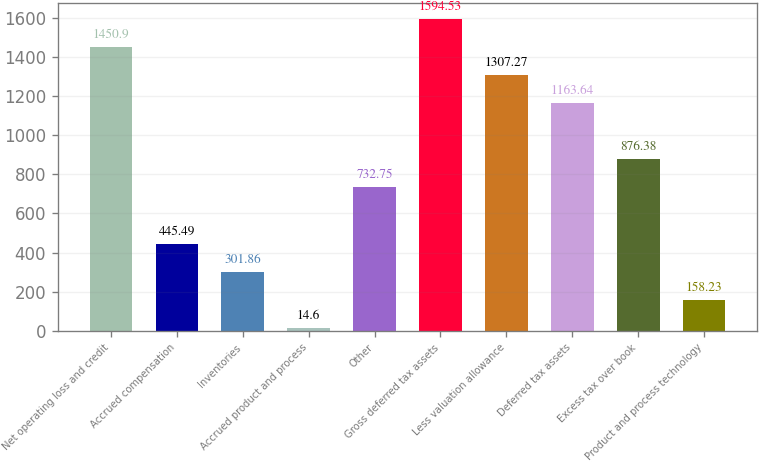Convert chart. <chart><loc_0><loc_0><loc_500><loc_500><bar_chart><fcel>Net operating loss and credit<fcel>Accrued compensation<fcel>Inventories<fcel>Accrued product and process<fcel>Other<fcel>Gross deferred tax assets<fcel>Less valuation allowance<fcel>Deferred tax assets<fcel>Excess tax over book<fcel>Product and process technology<nl><fcel>1450.9<fcel>445.49<fcel>301.86<fcel>14.6<fcel>732.75<fcel>1594.53<fcel>1307.27<fcel>1163.64<fcel>876.38<fcel>158.23<nl></chart> 